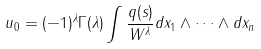<formula> <loc_0><loc_0><loc_500><loc_500>& u _ { 0 } = ( - 1 ) ^ { \lambda } \Gamma ( \lambda ) \int \frac { q ( s ) } { W ^ { \lambda } } d x _ { 1 } \wedge \dots \wedge d x _ { n }</formula> 